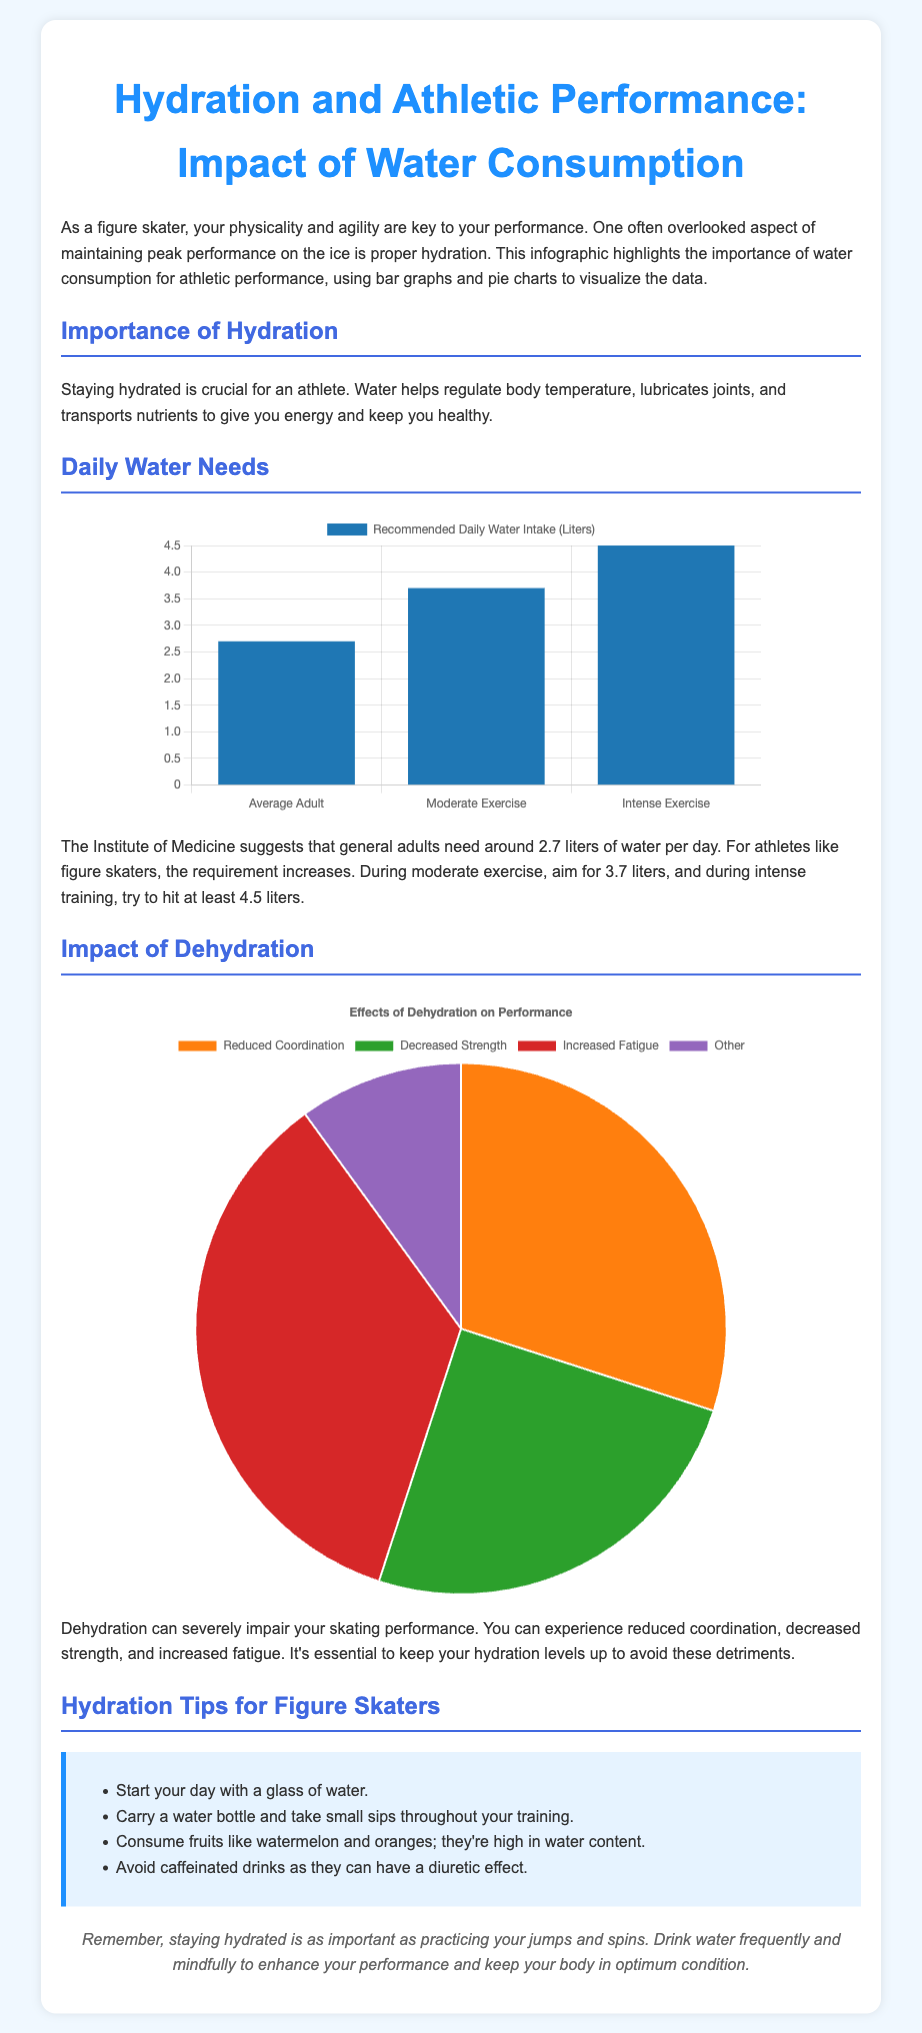What is the recommended daily water intake for an average adult? The document states that the Institute of Medicine suggests that general adults need around 2.7 liters of water per day.
Answer: 2.7 liters What is the recommended daily water intake during intense exercise? According to the infographic, for athletes during intense training, the requirement increases to at least 4.5 liters.
Answer: 4.5 liters What percentage of hydration effects is attributed to increased fatigue? The dehydration chart shows that increased fatigue accounts for 35% of hydration effects.
Answer: 35% What is the color code for reduced coordination in the dehydration pie chart? The document outlines that reduced coordination is represented by the color orange in the pie chart.
Answer: Orange What activity should figure skaters avoid to maintain hydration? The infographic suggests avoiding caffeinated drinks as they can have a diuretic effect.
Answer: Caffeinated drinks What is the relationship between hydration and joint lubrication? The document mentions that water lubricates joints, which is crucial for athletic performance.
Answer: Lubricates joints How many hydration tips are provided for figure skaters? The document provides a list of four hydration tips specifically tailored for figure skaters.
Answer: Four What visual representation is used to show the recommended daily water intake? The bar graph visually represents the recommended daily water intake for different activity levels.
Answer: Bar graph 